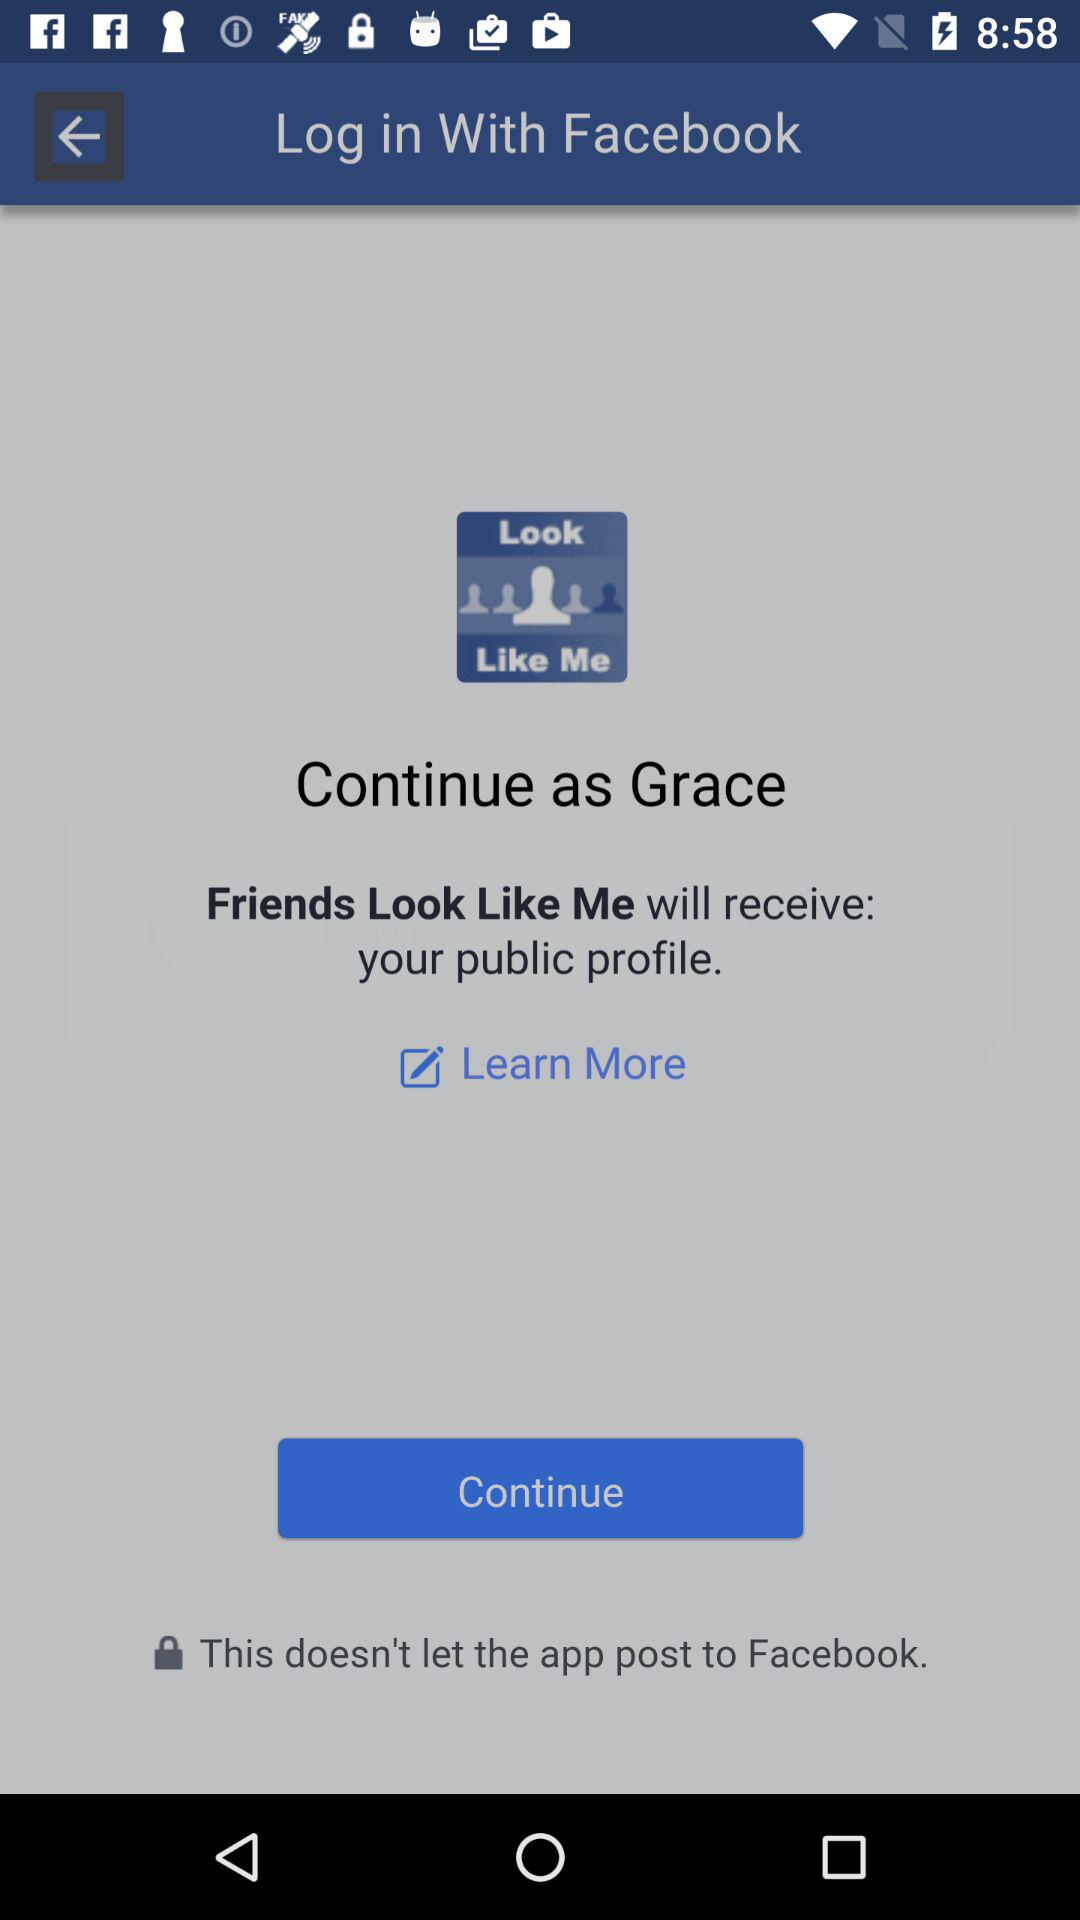What is the user name? The user name is Grace. 